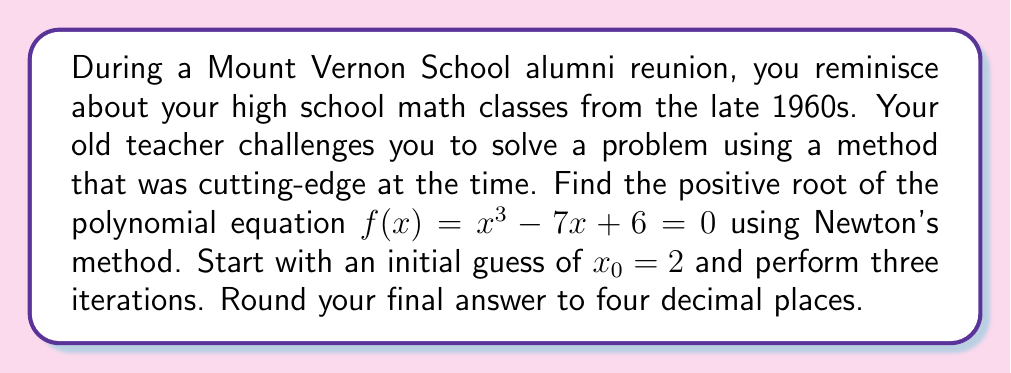Provide a solution to this math problem. Newton's method is an iterative technique for finding roots of equations. For a function $f(x)$, the formula for the next approximation is:

$$x_{n+1} = x_n - \frac{f(x_n)}{f'(x_n)}$$

where $f'(x)$ is the derivative of $f(x)$.

Step 1: Find $f'(x)$
$f(x) = x^3 - 7x + 6$
$f'(x) = 3x^2 - 7$

Step 2: Apply Newton's method for 3 iterations

Iteration 1:
$x_0 = 2$
$f(x_0) = 2^3 - 7(2) + 6 = 8 - 14 + 6 = 0$
$f'(x_0) = 3(2^2) - 7 = 12 - 7 = 5$

$x_1 = 2 - \frac{0}{5} = 2$

Iteration 2:
$x_1 = 2$
$f(x_1) = 2^3 - 7(2) + 6 = 0$
$f'(x_1) = 3(2^2) - 7 = 5$

$x_2 = 2 - \frac{0}{5} = 2$

Iteration 3:
$x_2 = 2$
$f(x_2) = 2^3 - 7(2) + 6 = 0$
$f'(x_2) = 3(2^2) - 7 = 5$

$x_3 = 2 - \frac{0}{5} = 2$

The method converges immediately to $x = 2$, which is indeed a root of the equation.
Answer: $2.0000$ 